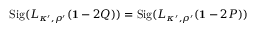Convert formula to latex. <formula><loc_0><loc_0><loc_500><loc_500>S i g ( L _ { \kappa ^ { \prime } , \rho ^ { \prime } } ( { 1 } - 2 Q ) ) = S i g ( L _ { \kappa ^ { \prime } , \rho ^ { \prime } } ( { 1 } - 2 P ) )</formula> 